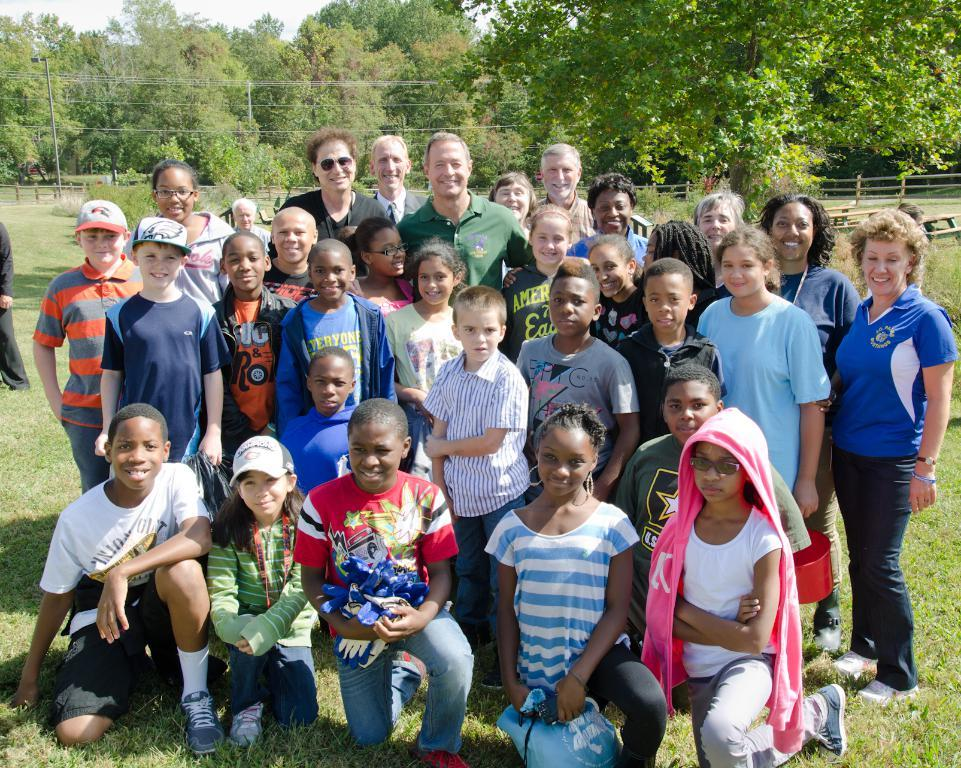How many people are in the image? There is a group of people in the image. What can be observed about the clothing of the people in the image? The people are wearing different color dresses. Are there any accessories visible on the people in the image? Yes, two people are wearing caps. What can be seen in the background of the image? There are many trees, a fence, a pole, and the sky visible in the background of the image. What type of coat is the person wearing in the image? There is no person wearing a coat in the image; the people are wearing different color dresses. What ingredients are used to make the stew in the image? There is no stew present in the image; it features a group of people and various elements in the background. 